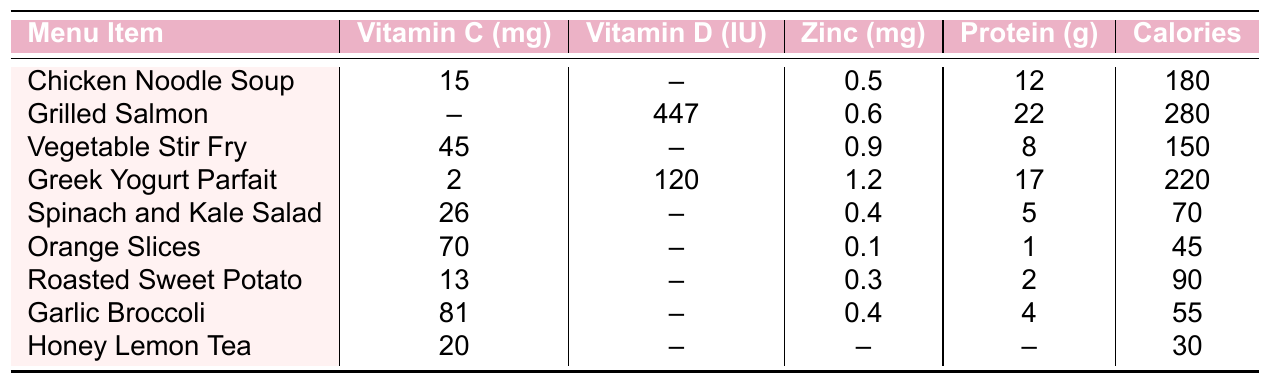What is the vitamin C content in Garlic Broccoli? From the table, the vitamin C content listed for Garlic Broccoli is 81 mg.
Answer: 81 mg Which menu item has the highest zinc content? By examining the zinc content in the table, Grilled Salmon has the highest zinc content at 0.6 mg.
Answer: Grilled Salmon What is the total protein content in Chicken Noodle Soup and Spinach and Kale Salad? The protein content for Chicken Noodle Soup is 12 g and for Spinach and Kale Salad is 5 g. Adding these together gives 12 + 5 = 17 g.
Answer: 17 g Does Honey Lemon Tea contain any vitamin D? The table shows that Honey Lemon Tea has "--" for vitamin D, indicating that it contains none.
Answer: No What is the average calorie content of the menu items? The sum of the calorie content is 180 + 280 + 150 + 220 + 70 + 45 + 90 + 55 + 30 = 1,120. There are 9 items, so the average is 1,120 / 9 = about 124.4.
Answer: About 124.4 Which item has the lowest calories? Upon reviewing the table, Honey Lemon Tea has the lowest calorie content at 30.
Answer: Honey Lemon Tea If you combine the vitamin C content from Orange Slices and Roasted Sweet Potato, what is the total? Orange Slices has 70 mg and Roasted Sweet Potato has 13 mg. Adding these values gives 70 + 13 = 83 mg of vitamin C.
Answer: 83 mg Is there any item with a vitamin D content of 0 IU? From the table, Chicken Noodle Soup, Vegetable Stir Fry, Spinach and Kale Salad, Orange Slices, Roasted Sweet Potato, Garlic Broccoli, and Honey Lemon Tea all have 0 IU of vitamin D.
Answer: Yes What is the protein difference between Grilled Salmon and Greek Yogurt Parfait? The protein in Grilled Salmon is 22 g, and for Greek Yogurt Parfait, it is 17 g. The difference is 22 - 17 = 5 g.
Answer: 5 g Which item contains the most vitamin C, and how much is it? The item with the highest vitamin C content is Garlic Broccoli with 81 mg.
Answer: Garlic Broccoli, 81 mg 